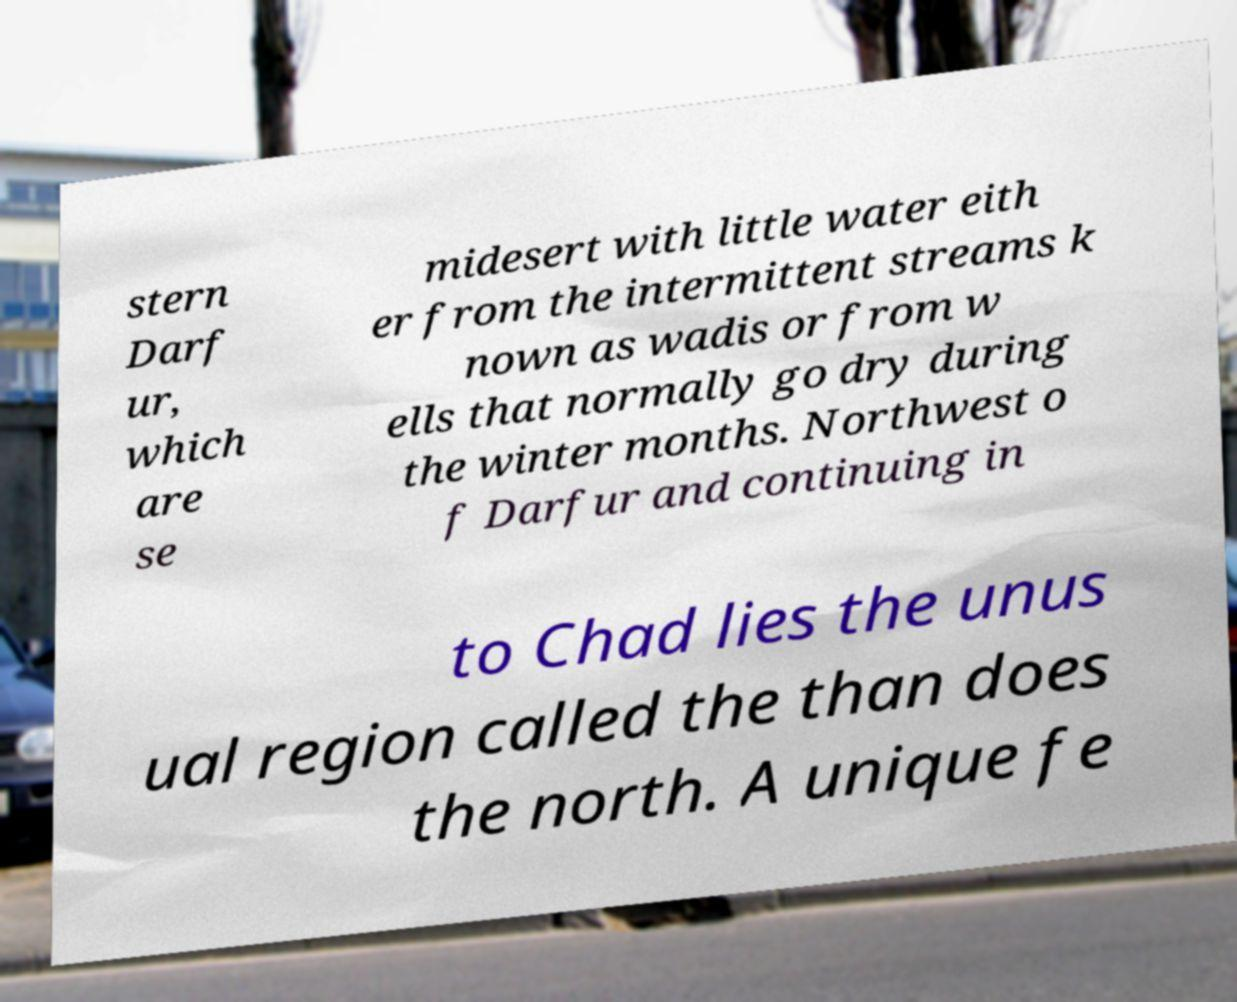There's text embedded in this image that I need extracted. Can you transcribe it verbatim? stern Darf ur, which are se midesert with little water eith er from the intermittent streams k nown as wadis or from w ells that normally go dry during the winter months. Northwest o f Darfur and continuing in to Chad lies the unus ual region called the than does the north. A unique fe 